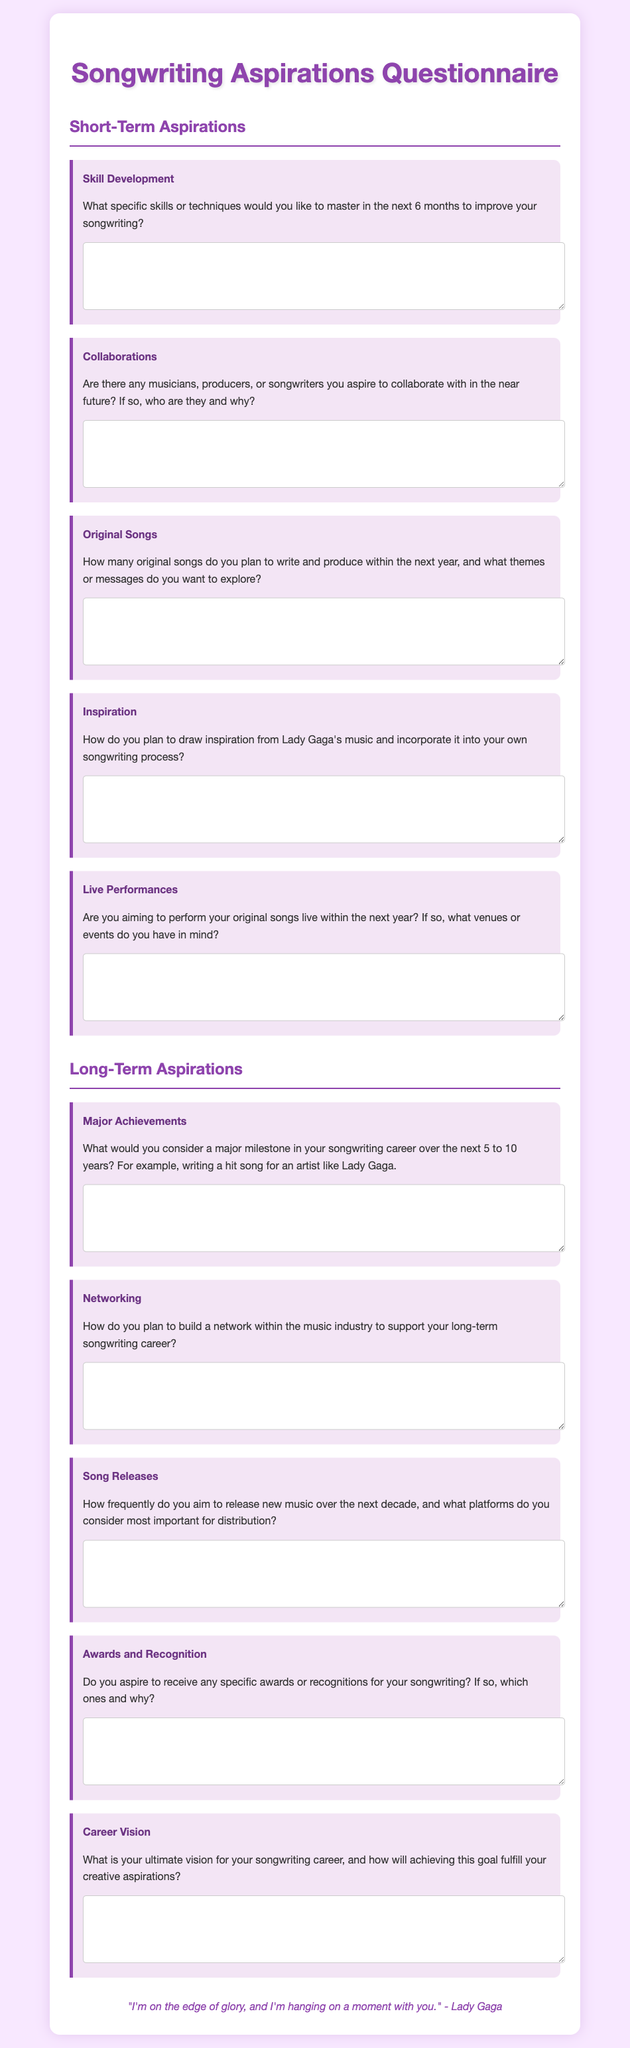What is the main title of this document? The main title of the document is presented in the header section and provides the focus of the content.
Answer: Songwriting Aspirations Questionnaire What color is the background of the document? The background color is specified in the style section and contributes to the visual appeal of the document.
Answer: #f8e8ff How many sections are there in the questionnaire? The document is structured into distinct sections for better organization of content, which the headings indicate.
Answer: 2 What is one topic listed under Short-Term Aspirations? The topics reflect various aspects of personal songwriting goals and are listed for respondents to consider.
Answer: Skill Development What is the inspiration quote at the end of the document? The quote is presented as an inspirational message relevant to the themes of the questionnaire.
Answer: "I'm on the edge of glory, and I'm hanging on a moment with you." - Lady Gaga What is the expected timeframe for planning to write and produce original songs? The document outlines time frames relevant to the aspirations and goals of the songwriter.
Answer: Next year What is one of the major achievements mentioned under Long-Term Aspirations? The prompt encourages respondents to think about significant accomplishments they hope to achieve in their career.
Answer: Writing a hit song for an artist like Lady Gaga How frequently does the questionnaire suggest aiming to release new music? The document prompts respondents to consider their long-term release strategies as part of their goals.
Answer: Over the next decade 